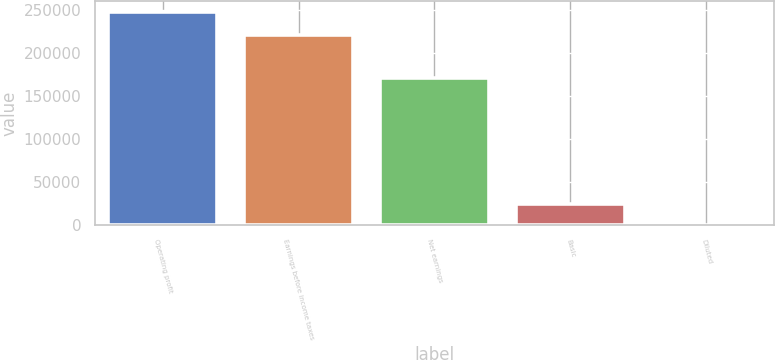<chart> <loc_0><loc_0><loc_500><loc_500><bar_chart><fcel>Operating profit<fcel>Earnings before income taxes<fcel>Net earnings<fcel>Basic<fcel>Diluted<nl><fcel>248072<fcel>221457<fcel>170990<fcel>24808.3<fcel>1.27<nl></chart> 